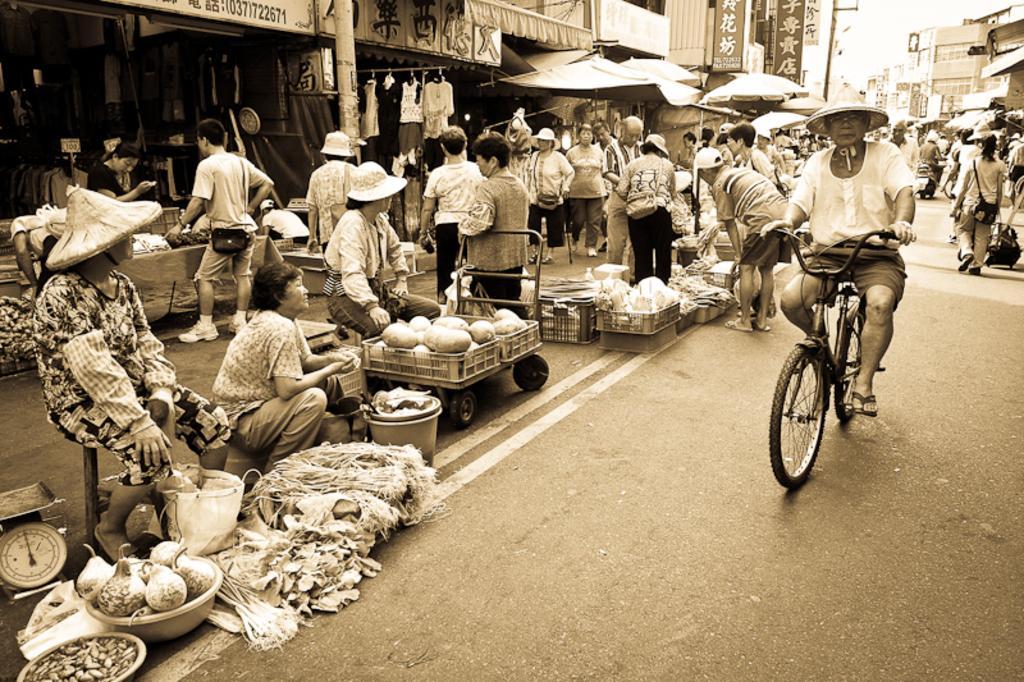Describe this image in one or two sentences. In this picture there are some people those who are sitting at the left side of the road in the image, they are selling the vegetables and there are other shops around the area of the image, there is a man who is riding the bicycle at the right side of the image, it seems to be a market place in the image. 